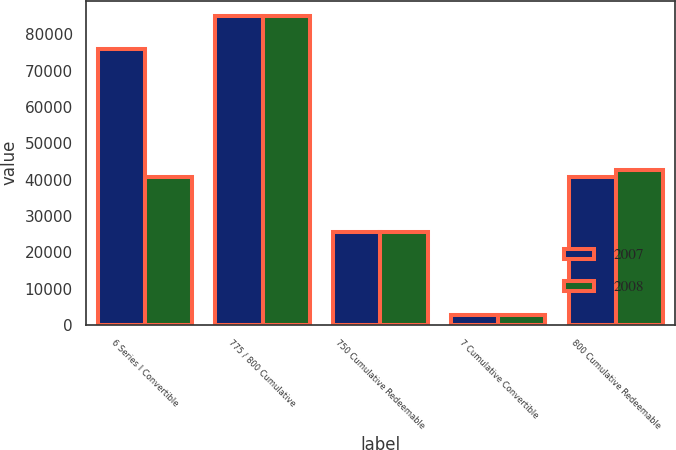Convert chart. <chart><loc_0><loc_0><loc_500><loc_500><stacked_bar_chart><ecel><fcel>6 Series I Convertible<fcel>775 / 800 Cumulative<fcel>750 Cumulative Redeemable<fcel>7 Cumulative Convertible<fcel>800 Cumulative Redeemable<nl><fcel>2007<fcel>75919<fcel>85070<fcel>25537<fcel>2639<fcel>40704<nl><fcel>2008<fcel>40704<fcel>85070<fcel>25537<fcel>2823<fcel>42549<nl></chart> 